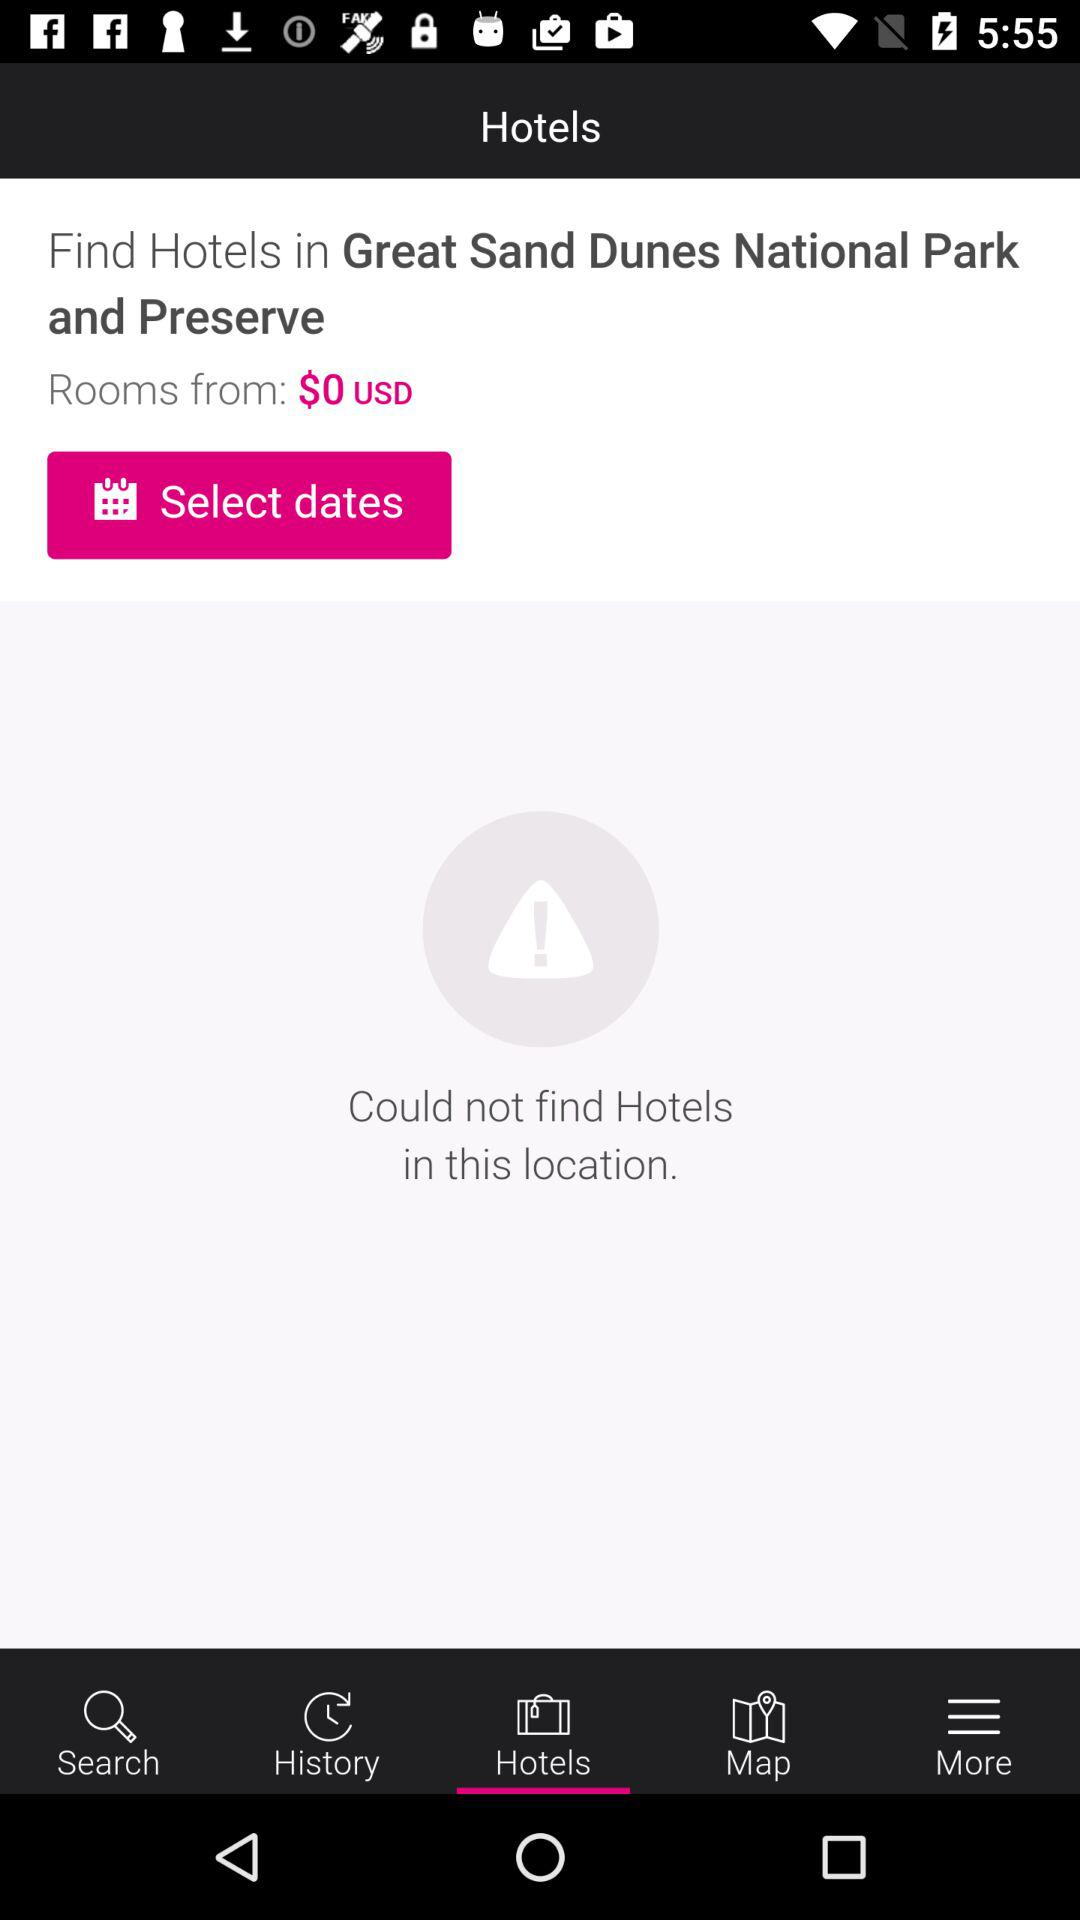Where to find hotels? Find hotels in the Great Sand Dunes National Park and Preserve. 